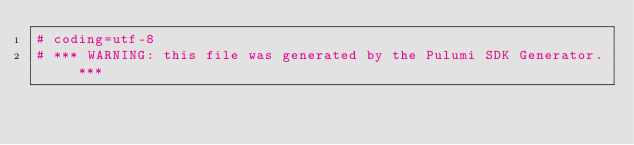Convert code to text. <code><loc_0><loc_0><loc_500><loc_500><_Python_># coding=utf-8
# *** WARNING: this file was generated by the Pulumi SDK Generator. ***</code> 